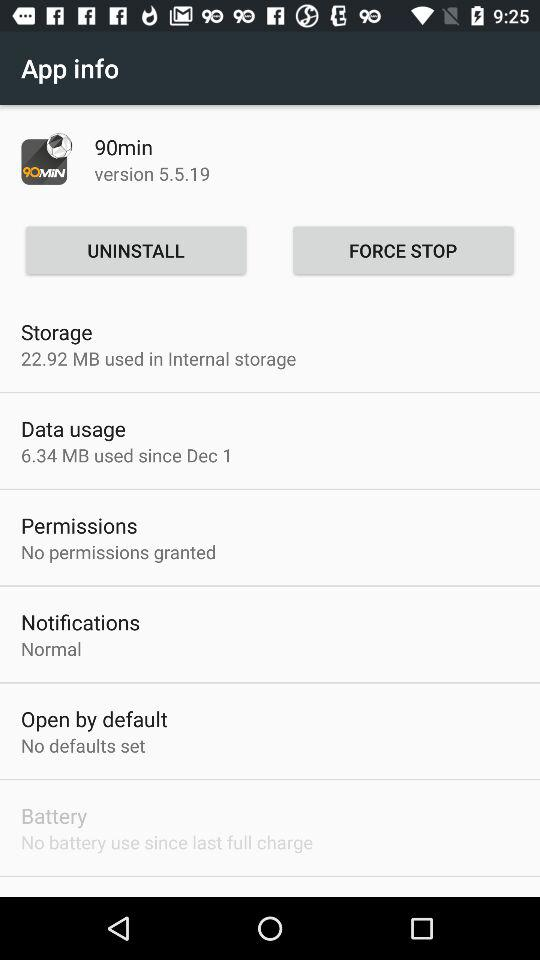How many MB of internal storage are used? The MB used is 22.92. 